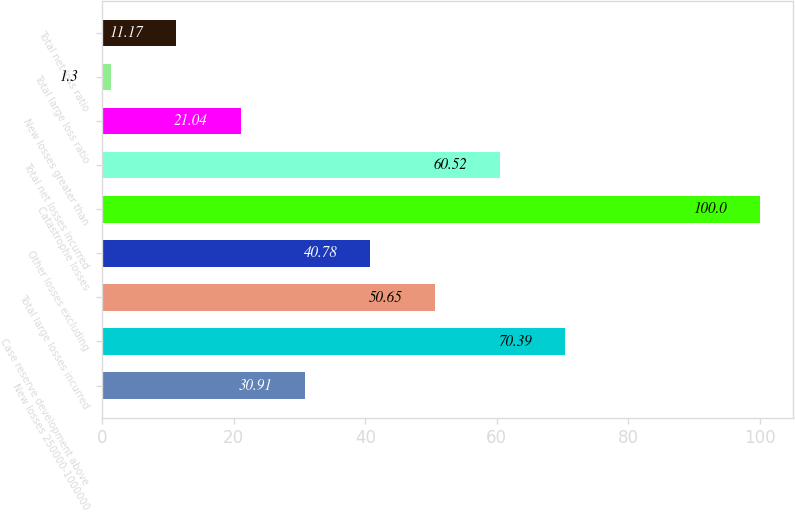Convert chart to OTSL. <chart><loc_0><loc_0><loc_500><loc_500><bar_chart><fcel>New losses 250000-1000000<fcel>Case reserve development above<fcel>Total large losses incurred<fcel>Other losses excluding<fcel>Catastrophe losses<fcel>Total net losses incurred<fcel>New losses greater than<fcel>Total large loss ratio<fcel>Total net loss ratio<nl><fcel>30.91<fcel>70.39<fcel>50.65<fcel>40.78<fcel>100<fcel>60.52<fcel>21.04<fcel>1.3<fcel>11.17<nl></chart> 